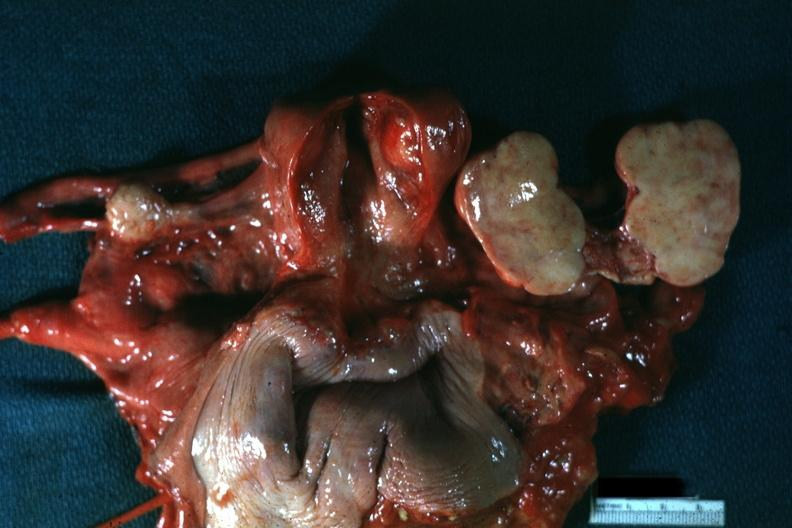how is all pelvic organs tumor mass opened like a book for this lesion?
Answer the question using a single word or phrase. Typical 